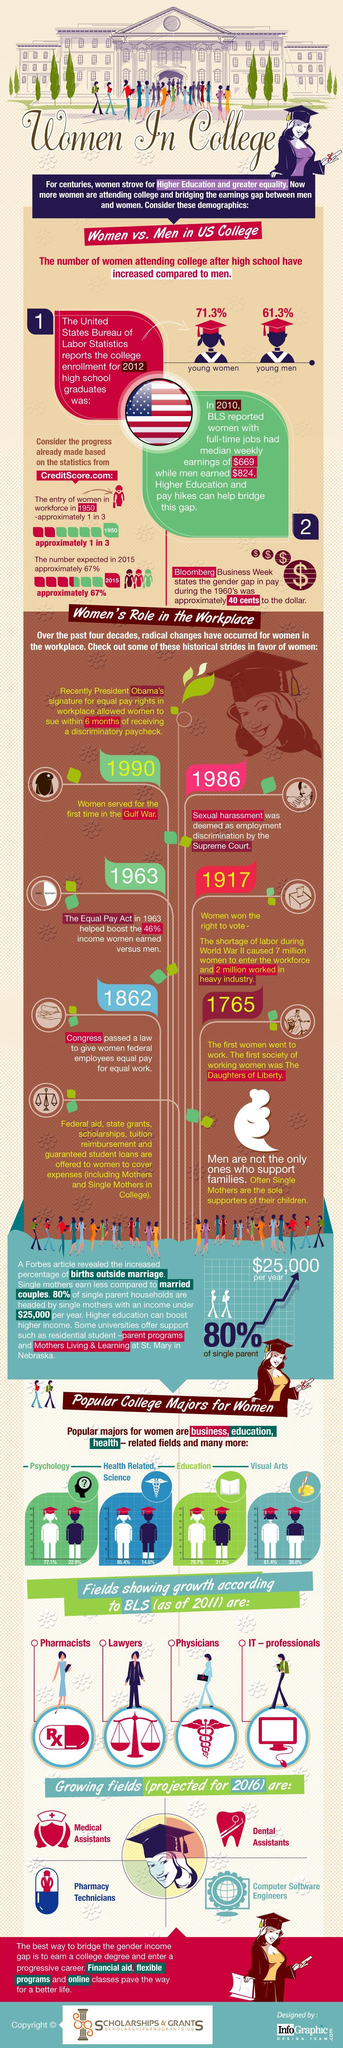In which year congress passed a law to give women federal employees equal pay for equal work?
Answer the question with a short phrase. 1862 In which year the first women went to work? 1765 In which year women served for the first time in the gulf war? 1990 